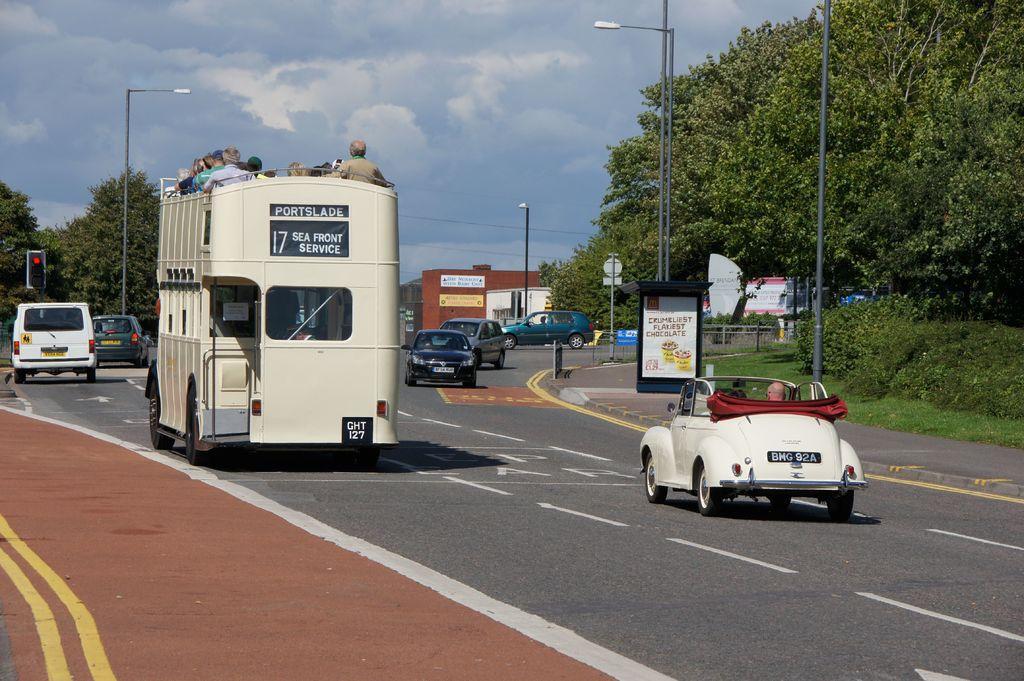In one or two sentences, can you explain what this image depicts? In this image there are vehicles on the road and there are people sitting inside the vehicles. There are traffic lights, light poles, boards. On the right side of the image there is a metal fence. There are plants, trees, buildings. At the top of the image there are clouds in the sky. 